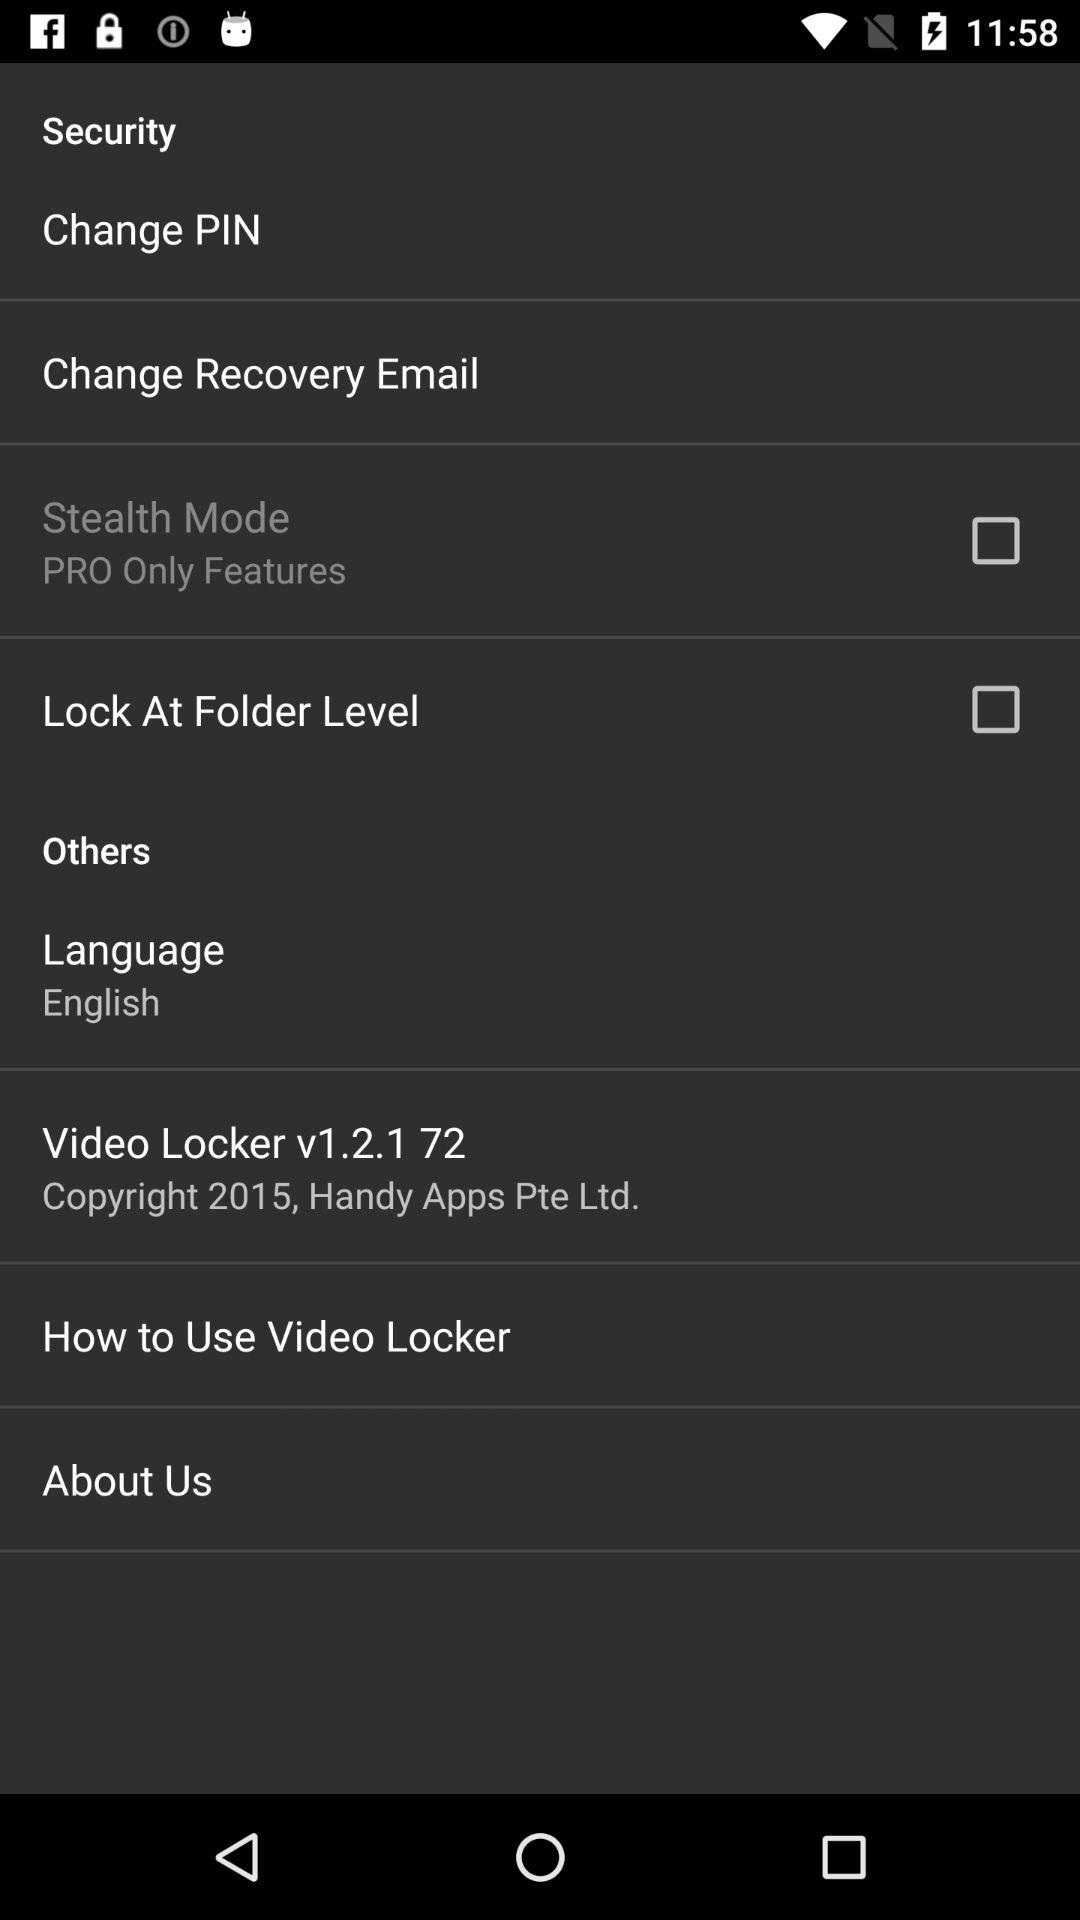What is the name of the application? The name of the application is "Video Locker". 